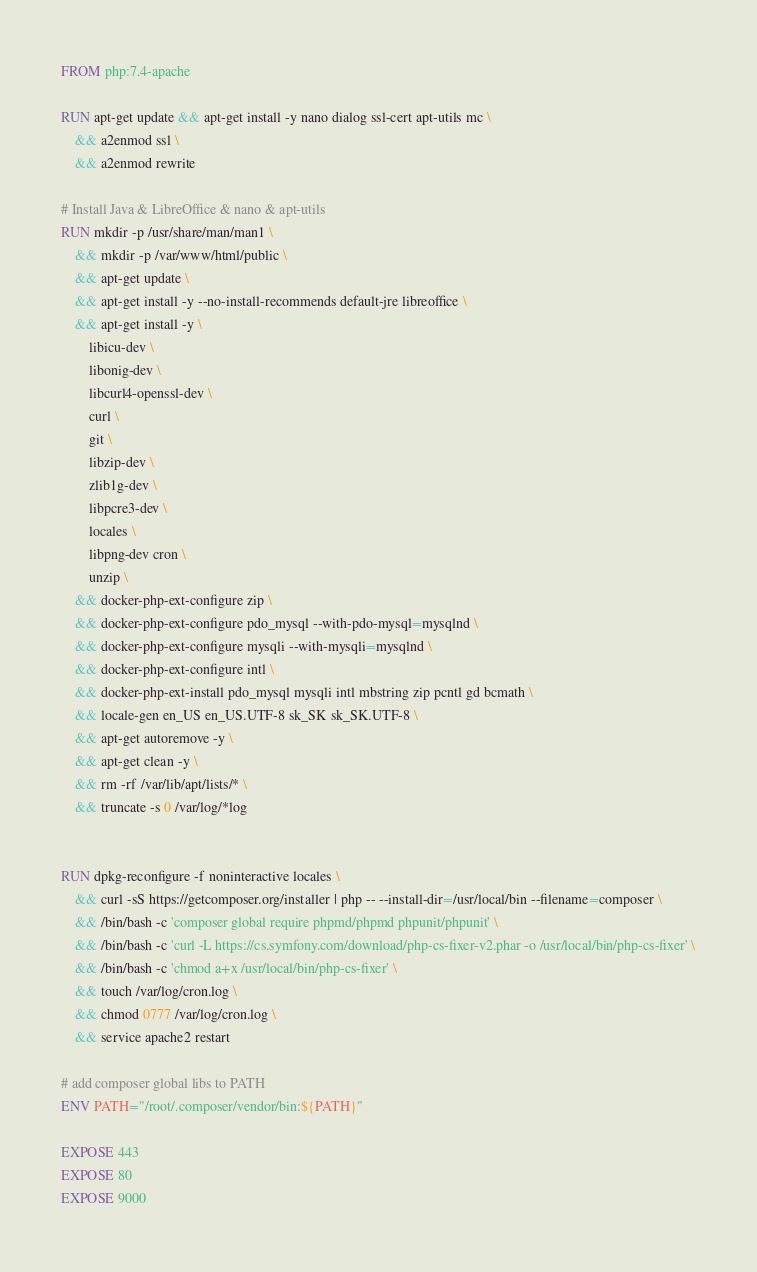<code> <loc_0><loc_0><loc_500><loc_500><_Dockerfile_>FROM php:7.4-apache

RUN apt-get update && apt-get install -y nano dialog ssl-cert apt-utils mc \
    && a2enmod ssl \
    && a2enmod rewrite

# Install Java & LibreOffice & nano & apt-utils
RUN mkdir -p /usr/share/man/man1 \
    && mkdir -p /var/www/html/public \
    && apt-get update \
    && apt-get install -y --no-install-recommends default-jre libreoffice \
    && apt-get install -y \
        libicu-dev \
        libonig-dev \
        libcurl4-openssl-dev \
        curl \
        git \
        libzip-dev \
        zlib1g-dev \
        libpcre3-dev \
        locales \
        libpng-dev cron \
        unzip \
    && docker-php-ext-configure zip \
    && docker-php-ext-configure pdo_mysql --with-pdo-mysql=mysqlnd \
    && docker-php-ext-configure mysqli --with-mysqli=mysqlnd \
    && docker-php-ext-configure intl \
    && docker-php-ext-install pdo_mysql mysqli intl mbstring zip pcntl gd bcmath \
    && locale-gen en_US en_US.UTF-8 sk_SK sk_SK.UTF-8 \
    && apt-get autoremove -y \
    && apt-get clean -y \
    && rm -rf /var/lib/apt/lists/* \
    && truncate -s 0 /var/log/*log


RUN dpkg-reconfigure -f noninteractive locales \
    && curl -sS https://getcomposer.org/installer | php -- --install-dir=/usr/local/bin --filename=composer \
    && /bin/bash -c 'composer global require phpmd/phpmd phpunit/phpunit' \
    && /bin/bash -c 'curl -L https://cs.symfony.com/download/php-cs-fixer-v2.phar -o /usr/local/bin/php-cs-fixer' \
    && /bin/bash -c 'chmod a+x /usr/local/bin/php-cs-fixer' \
    && touch /var/log/cron.log \
    && chmod 0777 /var/log/cron.log \
    && service apache2 restart

# add composer global libs to PATH
ENV PATH="/root/.composer/vendor/bin:${PATH}"

EXPOSE 443
EXPOSE 80
EXPOSE 9000
</code> 